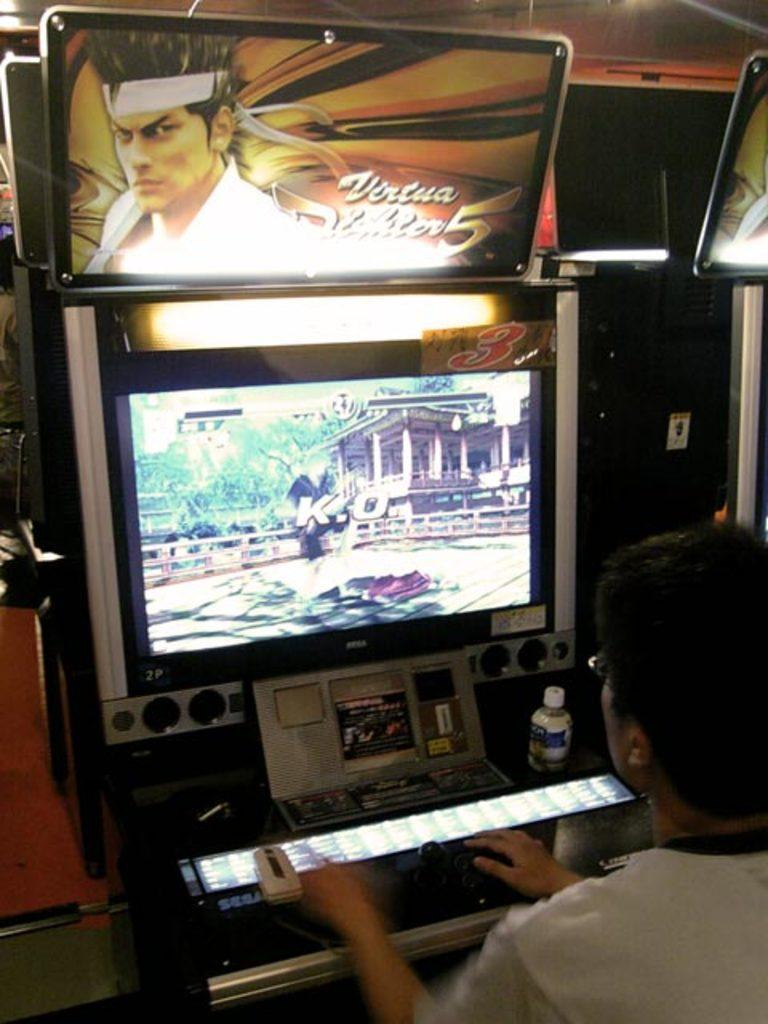<image>
Provide a brief description of the given image. A man playing a game that has K.O. currently on the screen. 